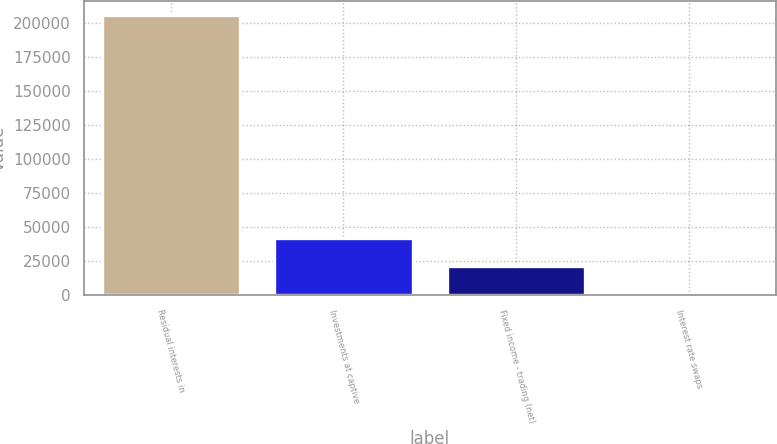Convert chart. <chart><loc_0><loc_0><loc_500><loc_500><bar_chart><fcel>Residual interests in<fcel>Investments at captive<fcel>Fixed income - trading (net)<fcel>Interest rate swaps<nl><fcel>205936<fcel>42247.2<fcel>21786.1<fcel>1325<nl></chart> 